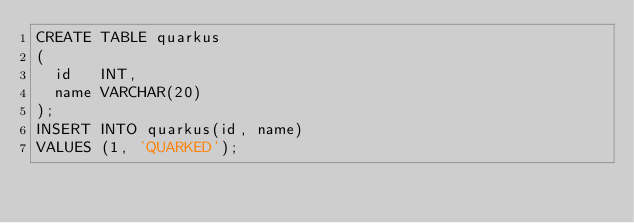<code> <loc_0><loc_0><loc_500><loc_500><_SQL_>CREATE TABLE quarkus
(
  id   INT,
  name VARCHAR(20)
);
INSERT INTO quarkus(id, name)
VALUES (1, 'QUARKED');</code> 